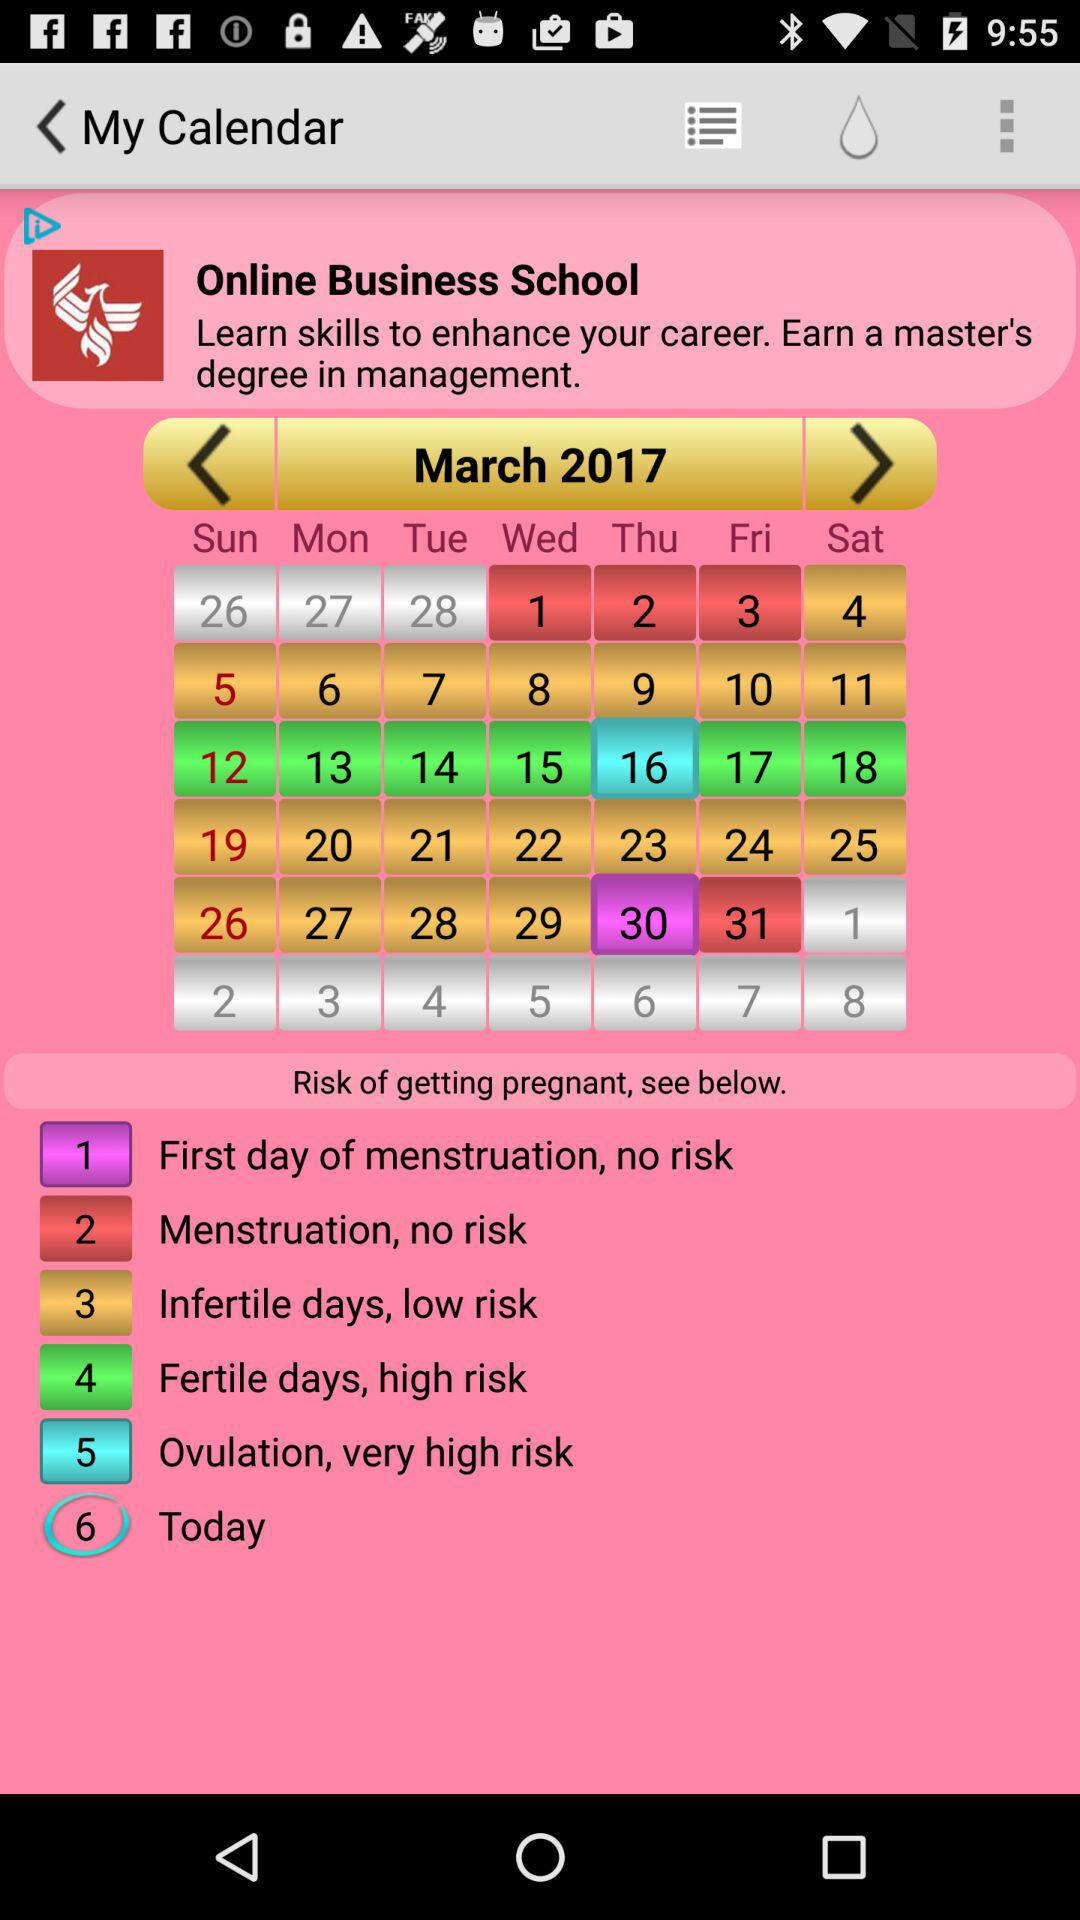Which prenatal option is on the 3rd of March? The prenatal option is "Menstruation, no risk". 